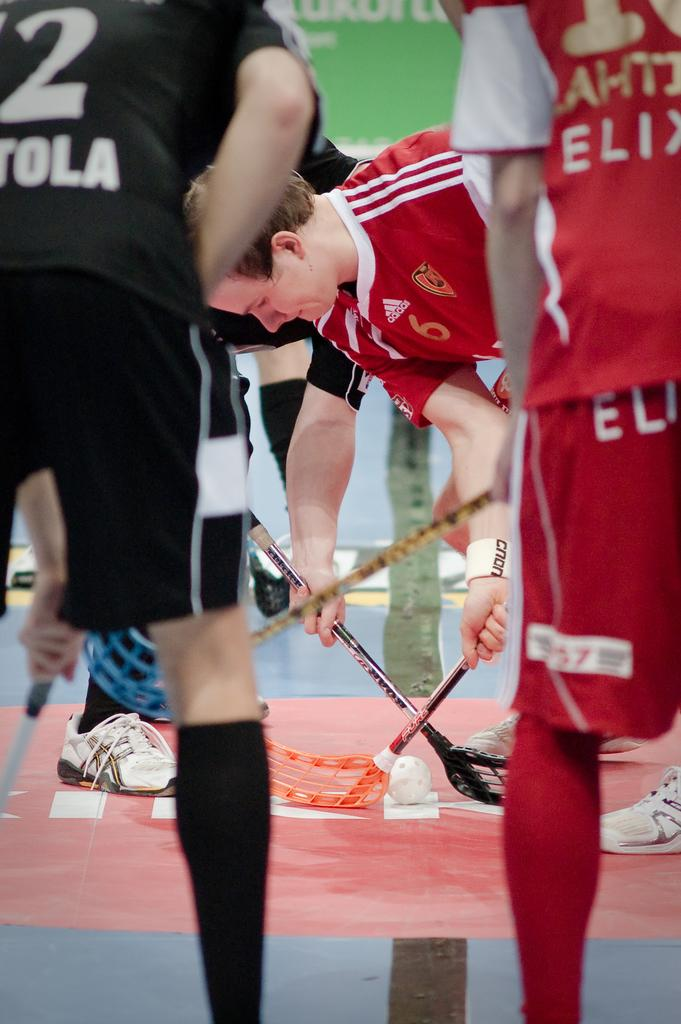<image>
Relay a brief, clear account of the picture shown. Player number 6 gets ready to hit the ball with his opponent 